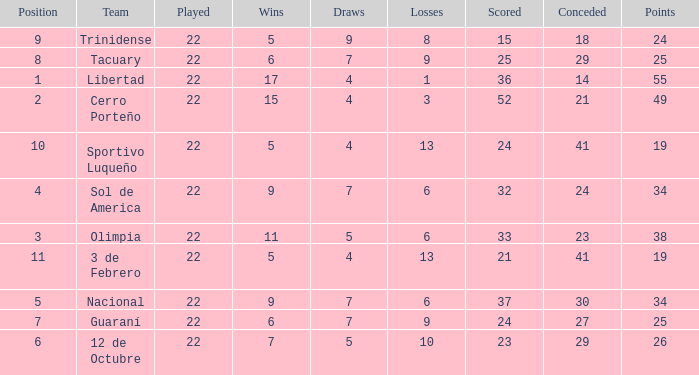What is the value scored when there were 19 points for the team 3 de Febrero? 21.0. 